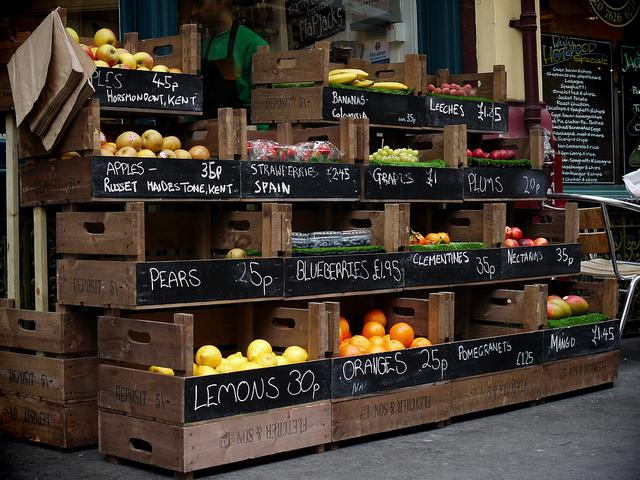What language must someone speak in order to understand what items are offered?

Choices:
A) english
B) spanish
C) french
D) italian english 